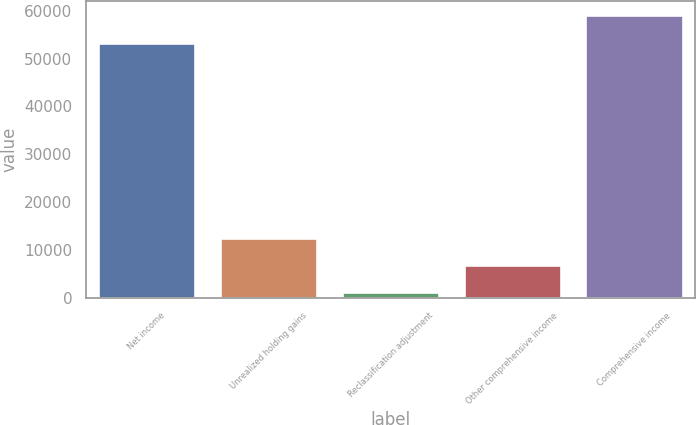Convert chart to OTSL. <chart><loc_0><loc_0><loc_500><loc_500><bar_chart><fcel>Net income<fcel>Unrealized holding gains<fcel>Reclassification adjustment<fcel>Other comprehensive income<fcel>Comprehensive income<nl><fcel>53358<fcel>12496.6<fcel>1107<fcel>6801.8<fcel>59052.8<nl></chart> 